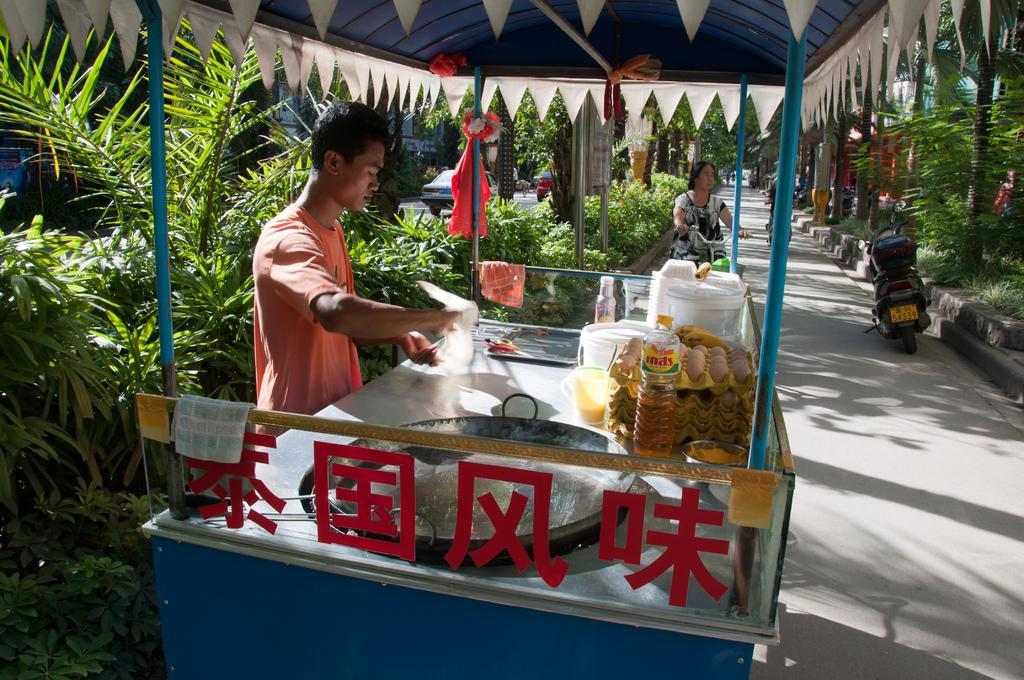Please provide a concise description of this image. In this image we can see there is a person standing in front of the food stall, behind the food stall there is a lady riding bicycle and there is a vehicle parked on the road. On the right side of the image there are trees and plants. On the left side of the image there are trees, plants and some moving vehicles are on the road. 